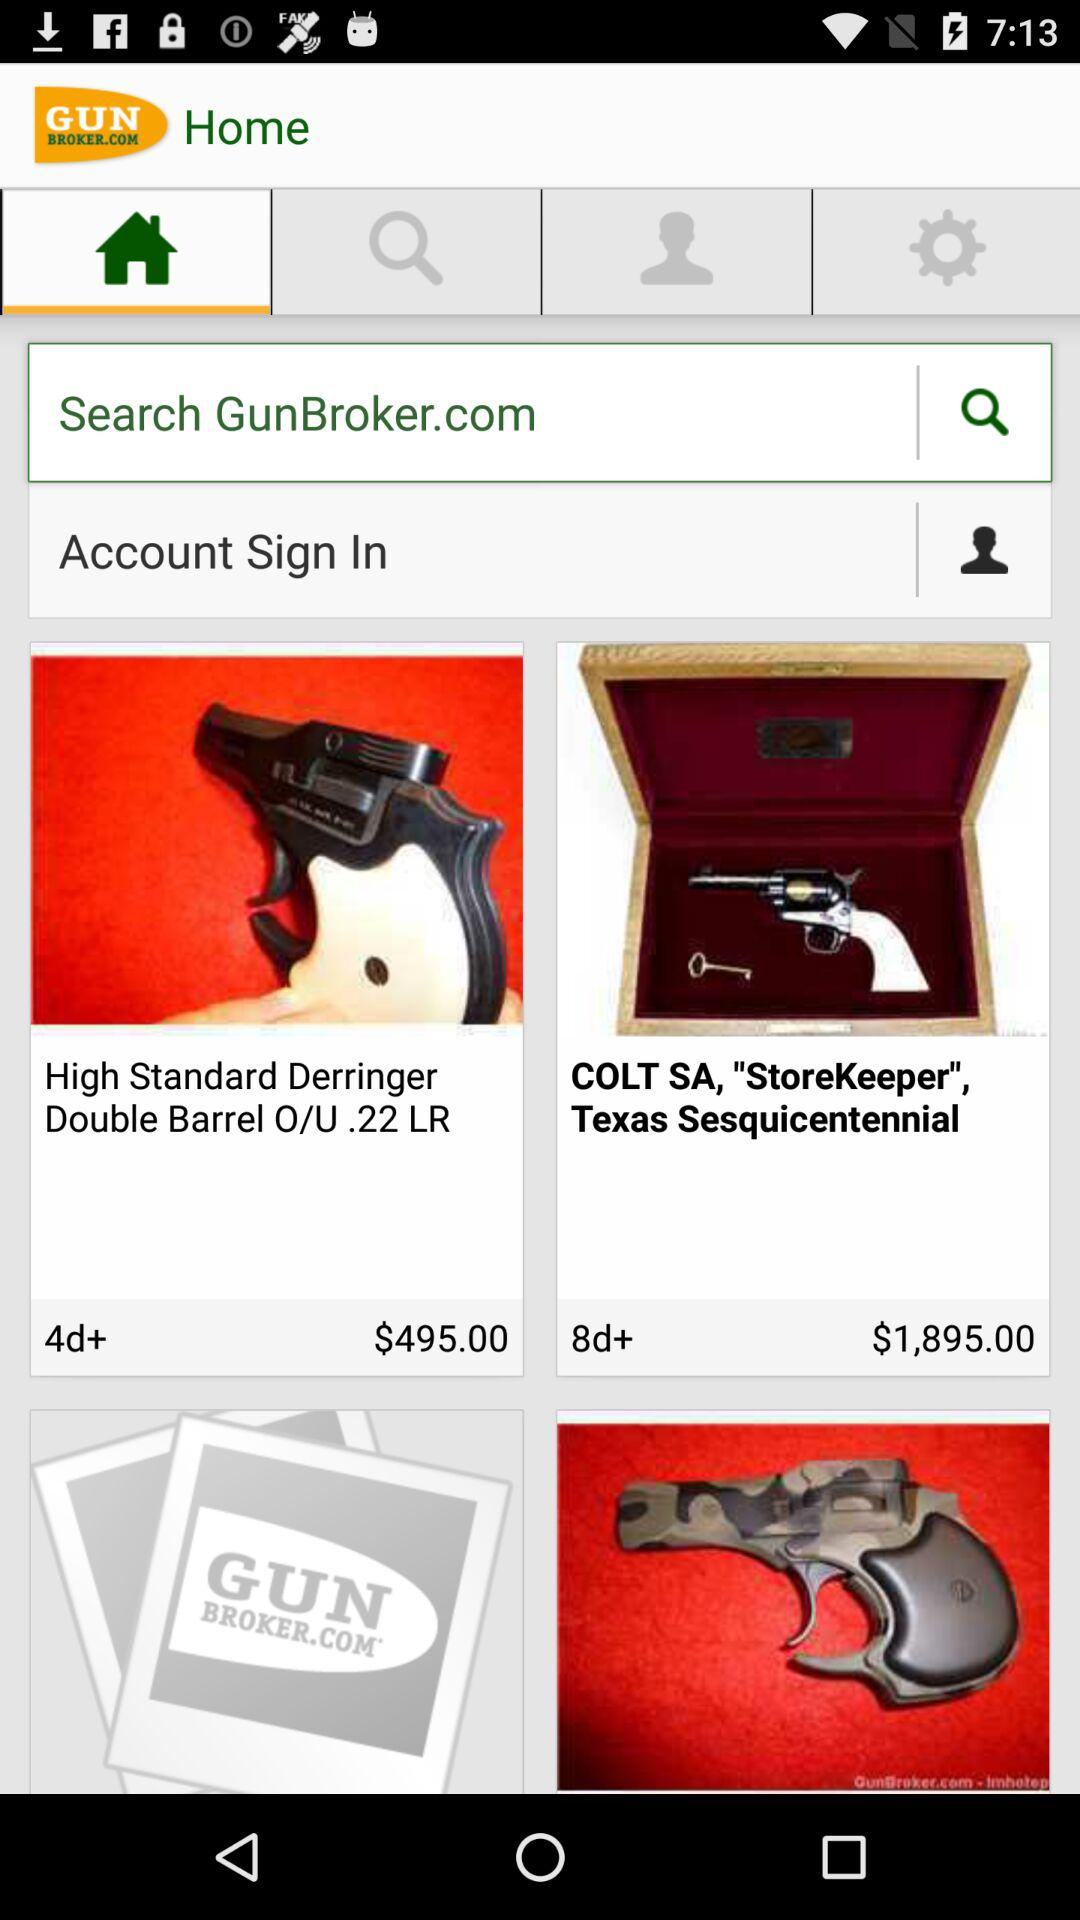Which currency is used? The used currency is dollars. 